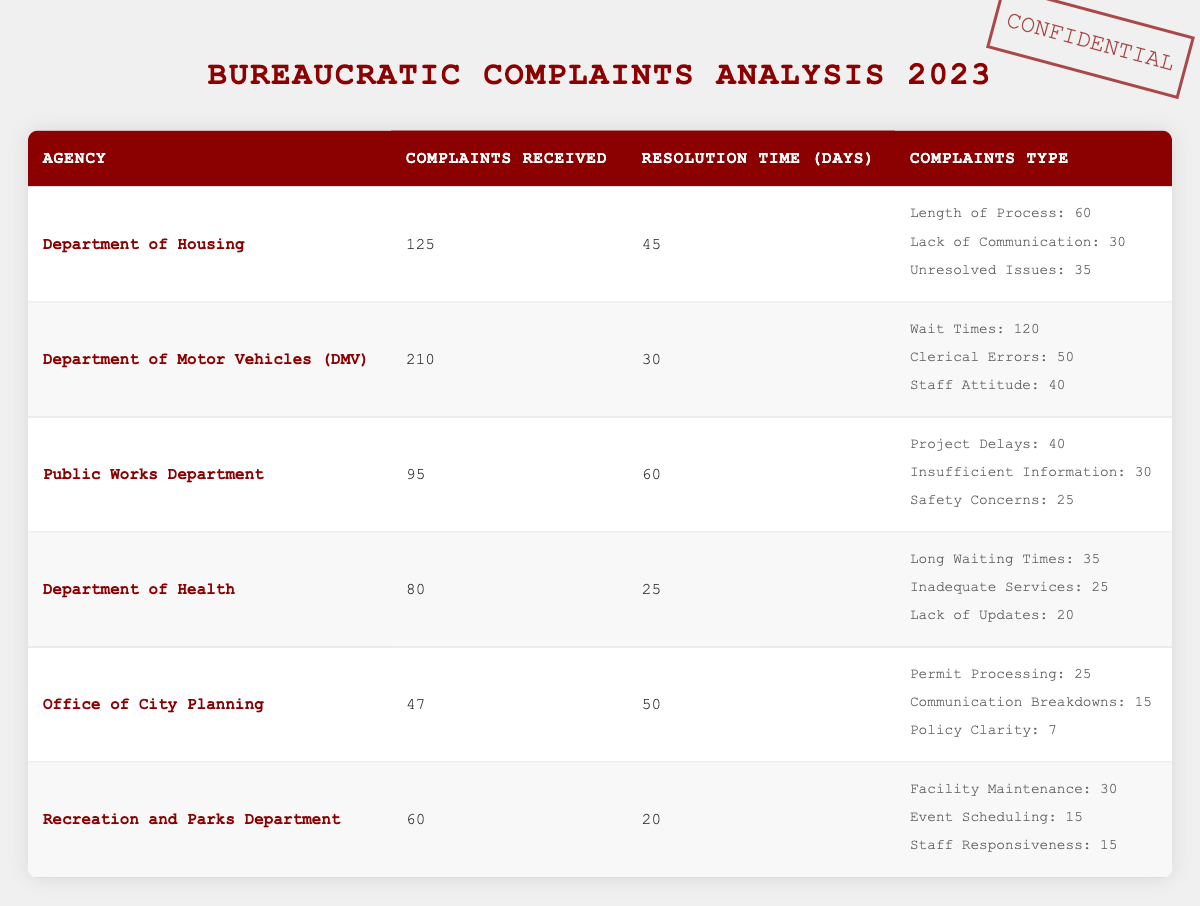What agency received the highest number of complaints? By examining the "Complaints Received" column, the Department of Motor Vehicles (DMV) shows the highest number with 210 complaints.
Answer: Department of Motor Vehicles (DMV) What is the average resolution time for all the agencies combined? To find the average resolution time, sum the resolution times (45 + 30 + 60 + 25 + 50 + 20 = 230) and divide by the number of agencies (6). Thus, the average is 230/6 = 38.33 days.
Answer: 38.33 days Did the Department of Health receive more than 80 complaints? The Department of Health received exactly 80 complaints, so it did not exceed this number.
Answer: No Which agency has the shortest resolution time, and what is that time? Looking at the "Resolution Time (Days)" column, the Department of Health has the shortest resolution time at 25 days.
Answer: Department of Health, 25 days How many complaints related to "wait times" were reported to the DMV? According to the complaints type under the DMV, 120 complaints were specifically about wait times.
Answer: 120 complaints What is the total number of complaints regarding “communication” issues across all agencies? From the table, communication issues include lack of communication from the Department of Housing (30) and communication breakdowns from the Office of City Planning (15). Adding these gives a total of 30 + 15 = 45 complaints related to communication.
Answer: 45 complaints Which two agencies have the longest resolution times, and what are those times? By comparing the resolution times, the Public Works Department has 60 days and the Department of Housing has 45 days. Therefore, they are the longest at 60 and 45 days, respectively.
Answer: Public Works Department, 60 days; Department of Housing, 45 days Is it true that the Recreation and Parks Department received fewer complaints than the Office of City Planning? The Recreation and Parks Department received 60 complaints while the Office of City Planning received 47 complaints. Thus, it is true that Recreation and Parks Department received more.
Answer: No What is the total number of complaints received by the Departments of Housing and Health combined? Adding the complaints from both the Department of Housing (125) and the Department of Health (80) results in a total of 125 + 80 = 205 complaints.
Answer: 205 complaints 